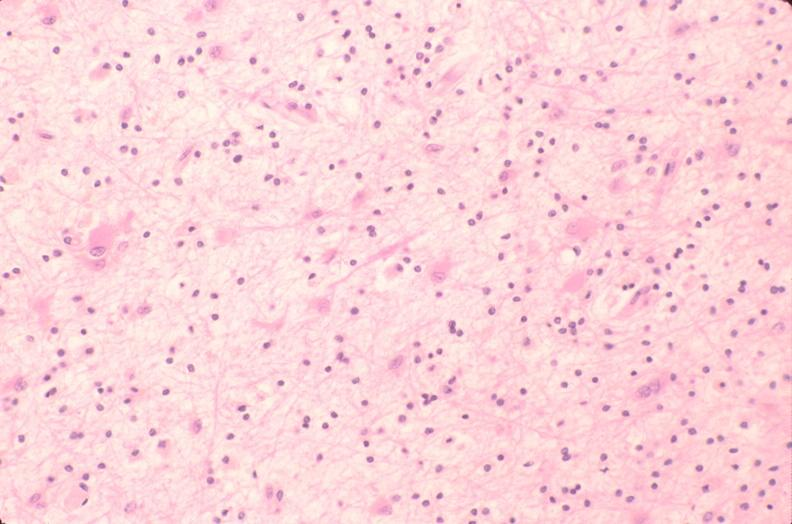what is present?
Answer the question using a single word or phrase. Nervous 